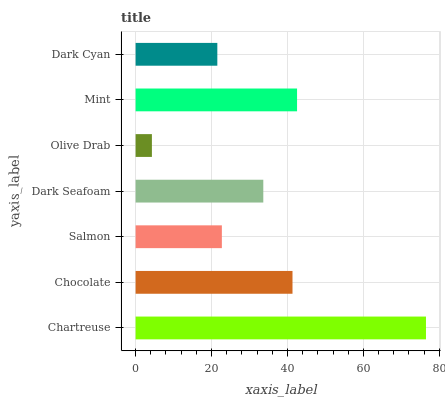Is Olive Drab the minimum?
Answer yes or no. Yes. Is Chartreuse the maximum?
Answer yes or no. Yes. Is Chocolate the minimum?
Answer yes or no. No. Is Chocolate the maximum?
Answer yes or no. No. Is Chartreuse greater than Chocolate?
Answer yes or no. Yes. Is Chocolate less than Chartreuse?
Answer yes or no. Yes. Is Chocolate greater than Chartreuse?
Answer yes or no. No. Is Chartreuse less than Chocolate?
Answer yes or no. No. Is Dark Seafoam the high median?
Answer yes or no. Yes. Is Dark Seafoam the low median?
Answer yes or no. Yes. Is Olive Drab the high median?
Answer yes or no. No. Is Mint the low median?
Answer yes or no. No. 